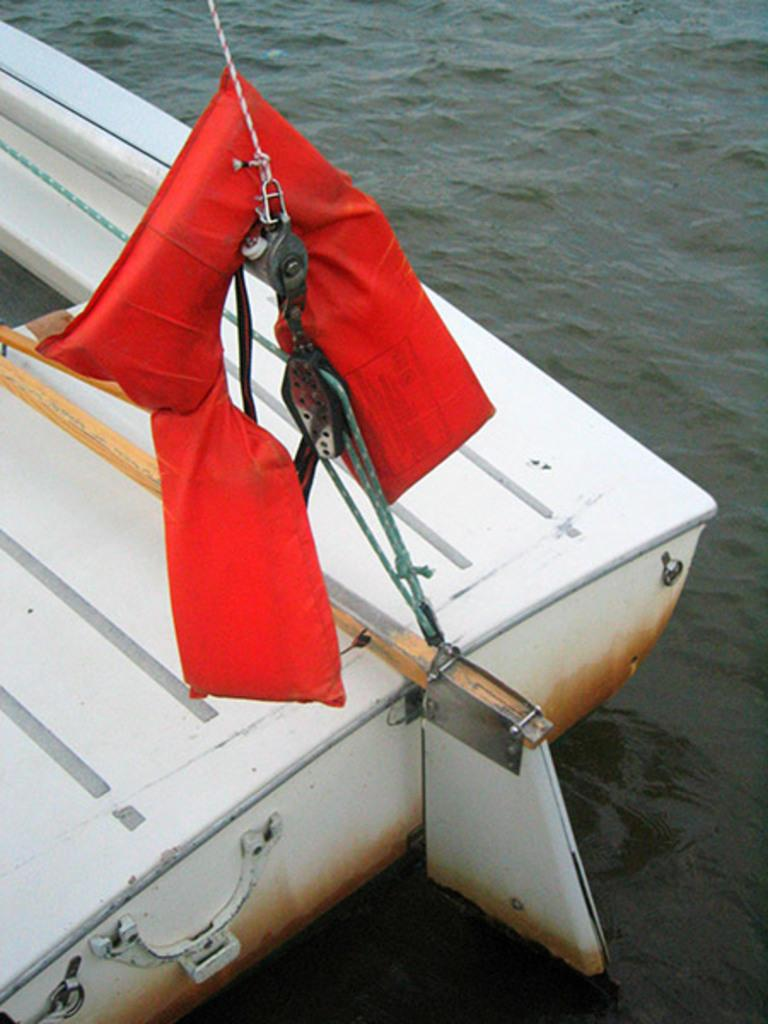What type of vehicle is in the image? There is a white-colored boat in the image. Where is the boat located? The boat is on the water. What is the color of the red-colored object in the image? The red-colored object in the image is red. What type of credit system is being used by the boat in the image? There is no indication of a credit system being used in the image; it features a white-colored boat on the water. Is the boat in the image experiencing any pain? Boats do not experience pain, as they are inanimate objects. 